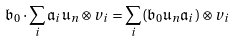Convert formula to latex. <formula><loc_0><loc_0><loc_500><loc_500>\mathfrak { b } _ { 0 } \cdot \sum _ { i } \mathfrak { a } _ { i } \mathfrak { u } _ { n } \otimes v _ { i } = \sum _ { i } ( \mathfrak { b } _ { 0 } \mathfrak { u } _ { n } \mathfrak { a } _ { i } ) \otimes v _ { i }</formula> 